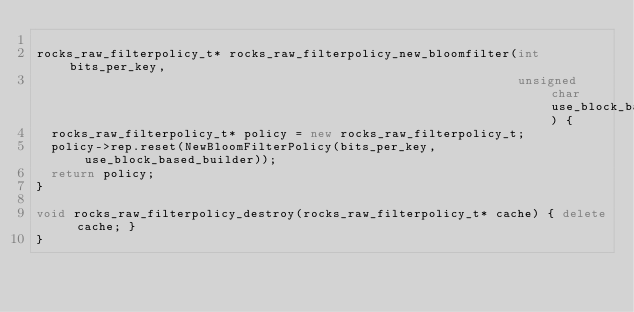<code> <loc_0><loc_0><loc_500><loc_500><_C++_>
rocks_raw_filterpolicy_t* rocks_raw_filterpolicy_new_bloomfilter(int bits_per_key,
                                                                 unsigned char use_block_based_builder) {
  rocks_raw_filterpolicy_t* policy = new rocks_raw_filterpolicy_t;
  policy->rep.reset(NewBloomFilterPolicy(bits_per_key, use_block_based_builder));
  return policy;
}

void rocks_raw_filterpolicy_destroy(rocks_raw_filterpolicy_t* cache) { delete cache; }
}
</code> 